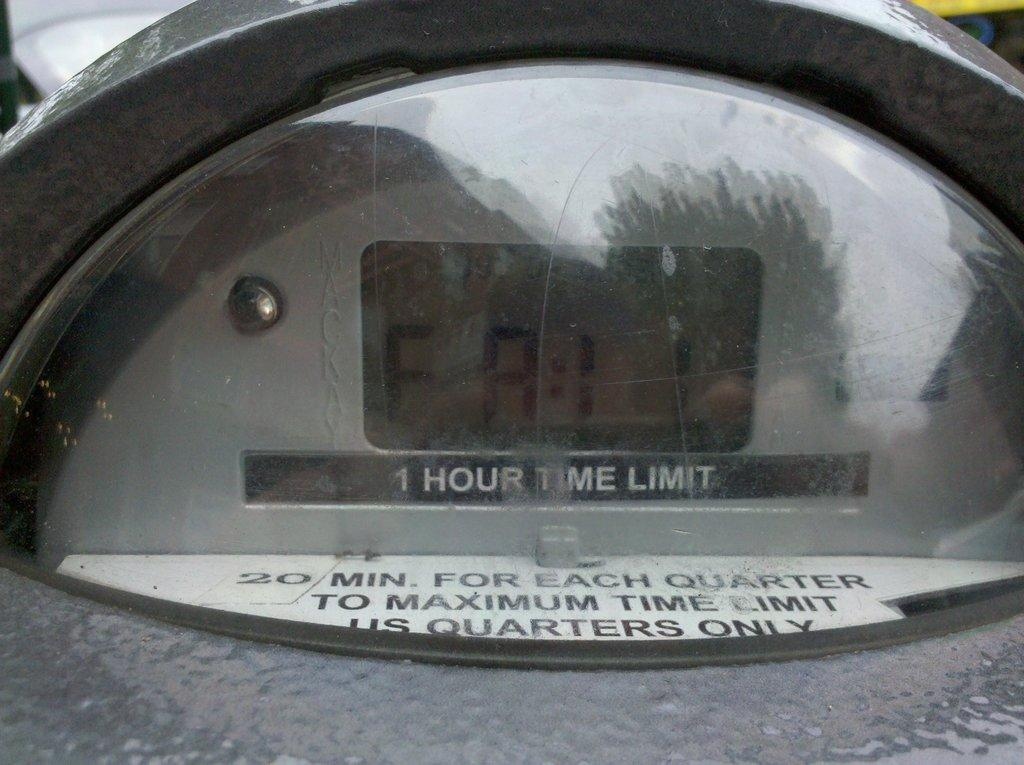<image>
Offer a succinct explanation of the picture presented. its a parking meter showing the time left for paid parking but it says FAIL 